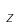<formula> <loc_0><loc_0><loc_500><loc_500>z</formula> 